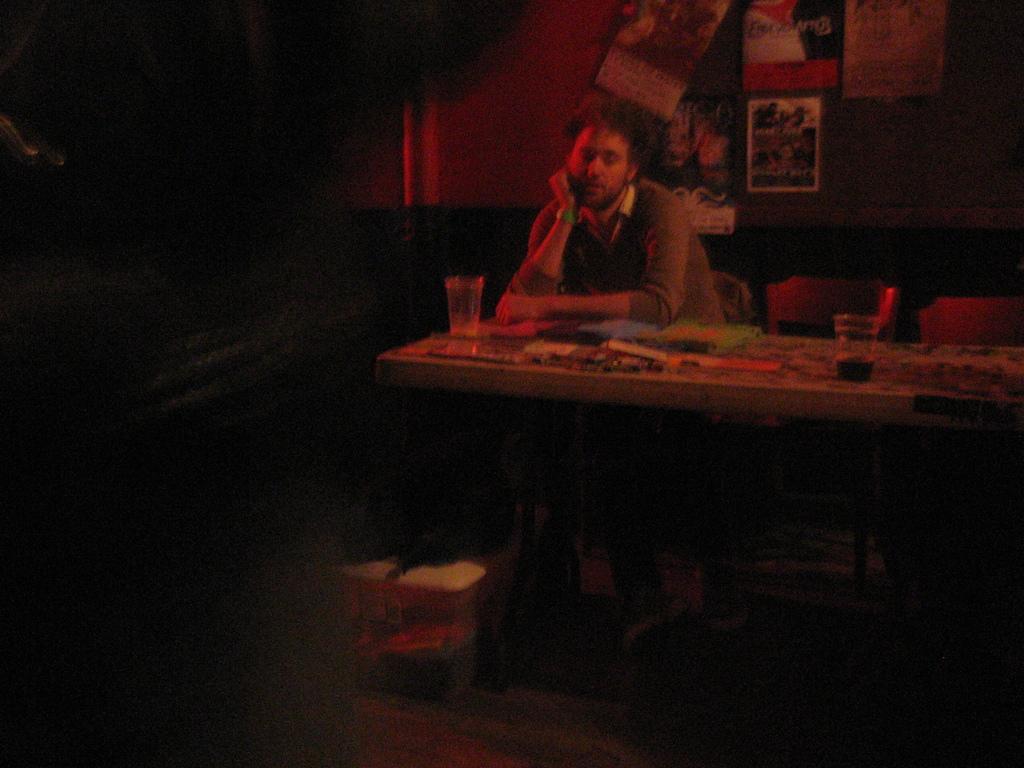Describe this image in one or two sentences. This person is sitting on a chair. In-front of this person there are glasses and things. On wall there are posters. Under the table there is a bag and box. 